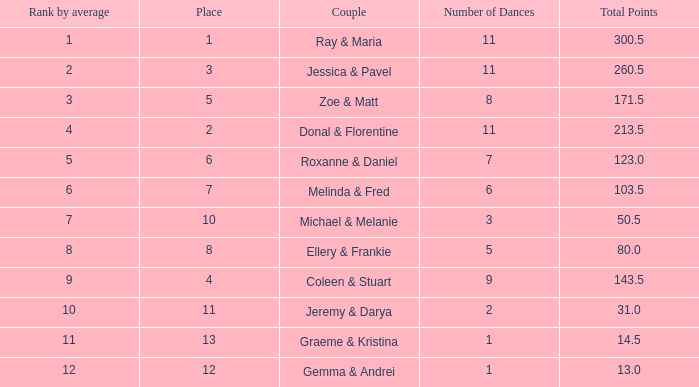If your rank by average is 9, what is the name of the couple? Coleen & Stuart. 